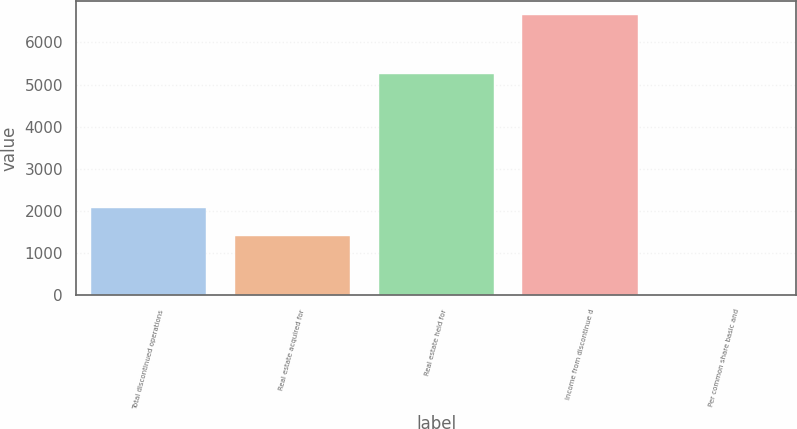Convert chart. <chart><loc_0><loc_0><loc_500><loc_500><bar_chart><fcel>Total discontinued operations<fcel>Real estate acquired for<fcel>Real estate held for<fcel>Income from discontinue d<fcel>Per common share basic and<nl><fcel>2067.19<fcel>1402<fcel>5250<fcel>6652<fcel>0.07<nl></chart> 